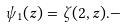<formula> <loc_0><loc_0><loc_500><loc_500>\psi _ { 1 } ( z ) = \zeta ( 2 , z ) . -</formula> 